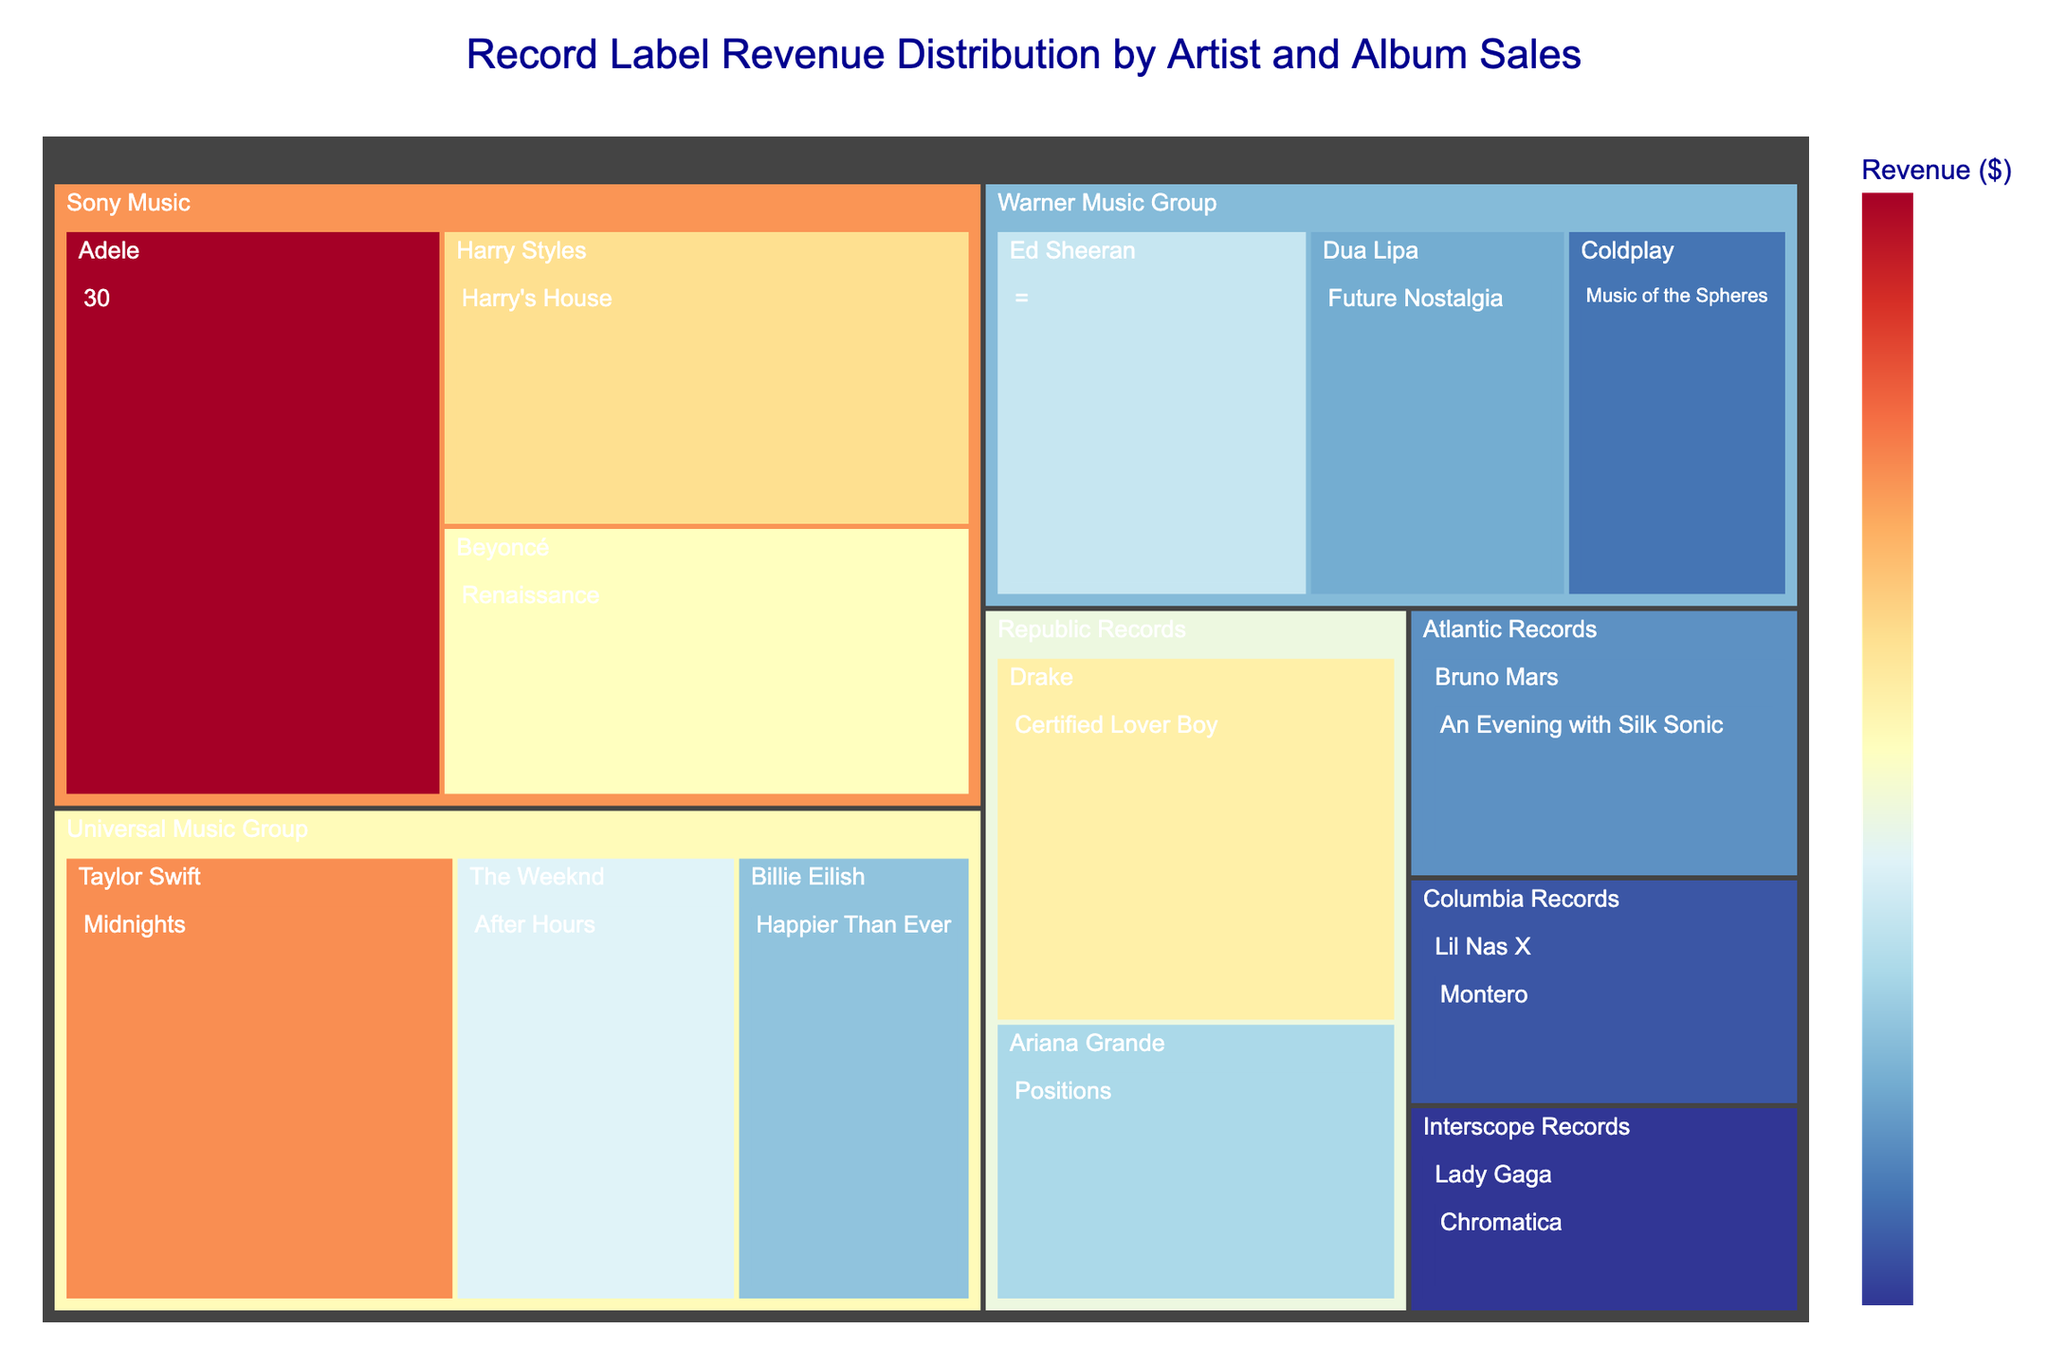What is the title of the Treemap plot? The title of the Treemap can usually be found at the top of the plot. It provides the primary context for the visual.
Answer: Record Label Revenue Distribution by Artist and Album Sales Which record label has the highest total revenue? To find the record label with the highest total revenue, sum the revenues of all artists under each label and compare them. Universal Music Group has revenues of $58 million, Sony Music has $72 million, Warner Music Group $43 million, Republic Records $37 million, Atlantic Records $13 million, and Columbia Records $11 million.
Answer: Sony Music What's the difference in revenue between Universal Music Group's top earning album and Warner Music Group's top earning album? Universal Music Group's top album ("Midnights" by Taylor Swift) has a revenue of $25 million. Warner Music Group's top album ("=" by Ed Sheeran) has a revenue of $17 million. The difference is $25 million - $17 million.
Answer: $8 million How many albums generate at least $20 million in revenue? Count the number of albums with revenues of $20 million or more. There are "Midnights" by Taylor Swift ($25M), "30" by Adele ($30M), "Harry's House" by Harry Styles ($22M), and "Renaissance" by Beyoncé ($20M).
Answer: 4 Which artist from Republic Records has the highest revenue, and what is it? Look for artists labeled under Republic Records and compare their revenues. Drake's album "Certified Lover Boy" has the highest revenue under Republic Records with $21 million.
Answer: Drake, $21 million How does the revenue of 'Midnights' by Taylor Swift compare to the combined revenue of albums from Interscope Records and Atlantic Records? "Midnights" by Taylor Swift has a revenue of $25 million. Interscope Records' "Chromatica" by Lady Gaga has a revenue of $10 million, and Atlantic Records' "An Evening with Silk Sonic" by Bruno Mars has a revenue of $13 million. The combined revenue for the two labels is $10 million + $13 million. Compare $25 million to $23 million.
Answer: $2 million more Which record label has the least number of albums, and how many albums do they have? Count the albums represented by each label. Columbia Records has only one album: "Montero" by Lil Nas X. All other labels have more than one album.
Answer: Columbia Records, 1 What is the total revenue generated by artists under the Warner Music Group label? Sum the revenues for all artists under Warner Music Group: Ed Sheeran ("=") $17M, Dua Lipa ("Future Nostalgia") $14M, and Coldplay ("Music of the Spheres") $12M. The total is $17M + $14M + $12M.
Answer: $43 million 